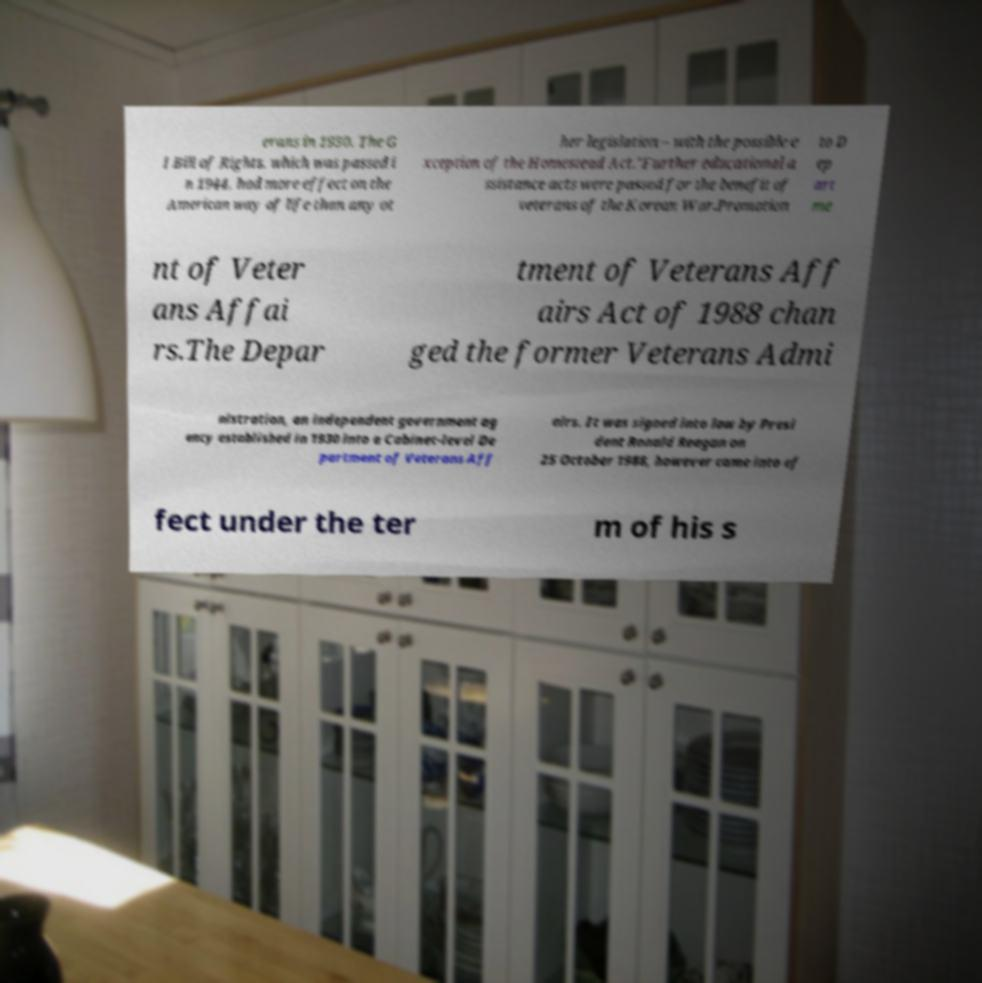Please identify and transcribe the text found in this image. erans in 1930. The G I Bill of Rights, which was passed i n 1944, had more effect on the American way of life than any ot her legislation – with the possible e xception of the Homestead Act."Further educational a ssistance acts were passed for the benefit of veterans of the Korean War.Promotion to D ep art me nt of Veter ans Affai rs.The Depar tment of Veterans Aff airs Act of 1988 chan ged the former Veterans Admi nistration, an independent government ag ency established in 1930 into a Cabinet-level De partment of Veterans Aff airs. It was signed into law by Presi dent Ronald Reagan on 25 October 1988, however came into ef fect under the ter m of his s 